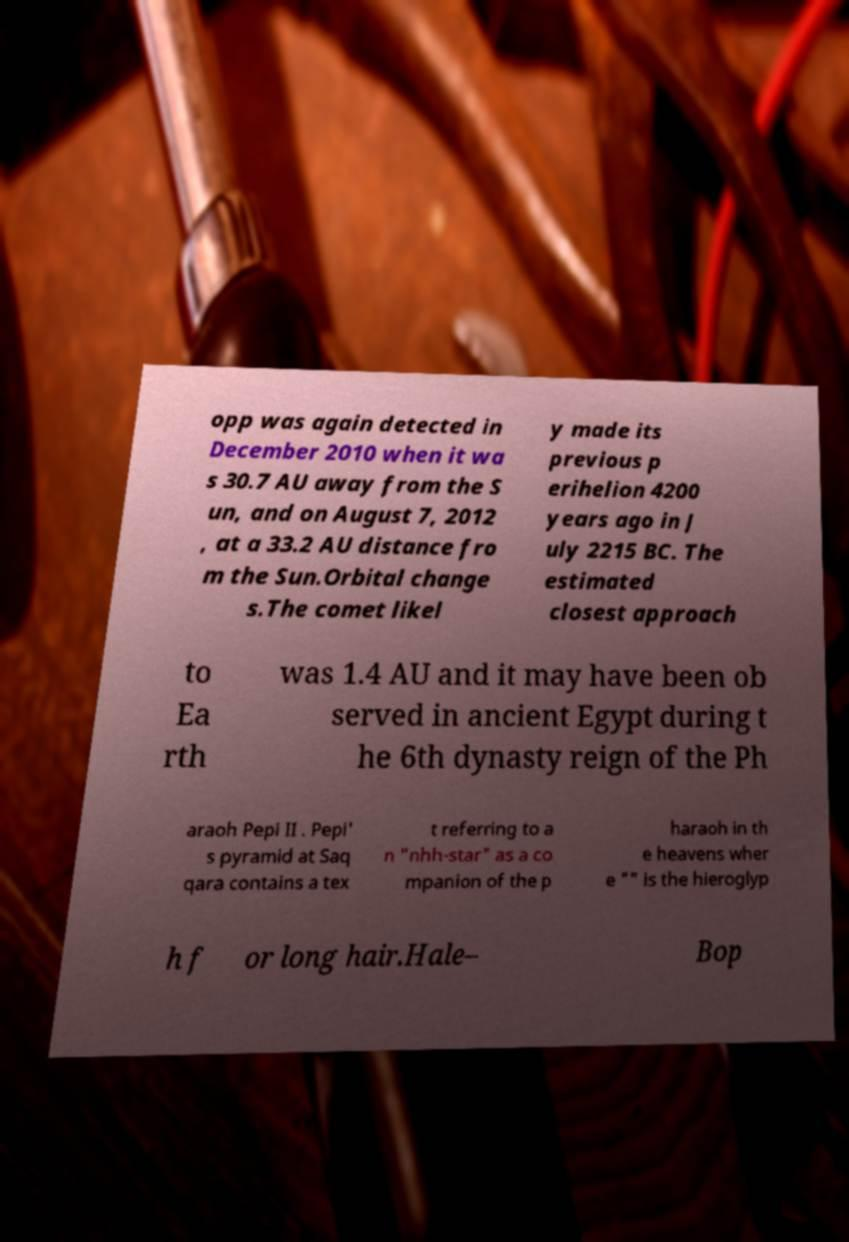What messages or text are displayed in this image? I need them in a readable, typed format. opp was again detected in December 2010 when it wa s 30.7 AU away from the S un, and on August 7, 2012 , at a 33.2 AU distance fro m the Sun.Orbital change s.The comet likel y made its previous p erihelion 4200 years ago in J uly 2215 BC. The estimated closest approach to Ea rth was 1.4 AU and it may have been ob served in ancient Egypt during t he 6th dynasty reign of the Ph araoh Pepi II . Pepi' s pyramid at Saq qara contains a tex t referring to a n "nhh-star" as a co mpanion of the p haraoh in th e heavens wher e "" is the hieroglyp h f or long hair.Hale– Bop 